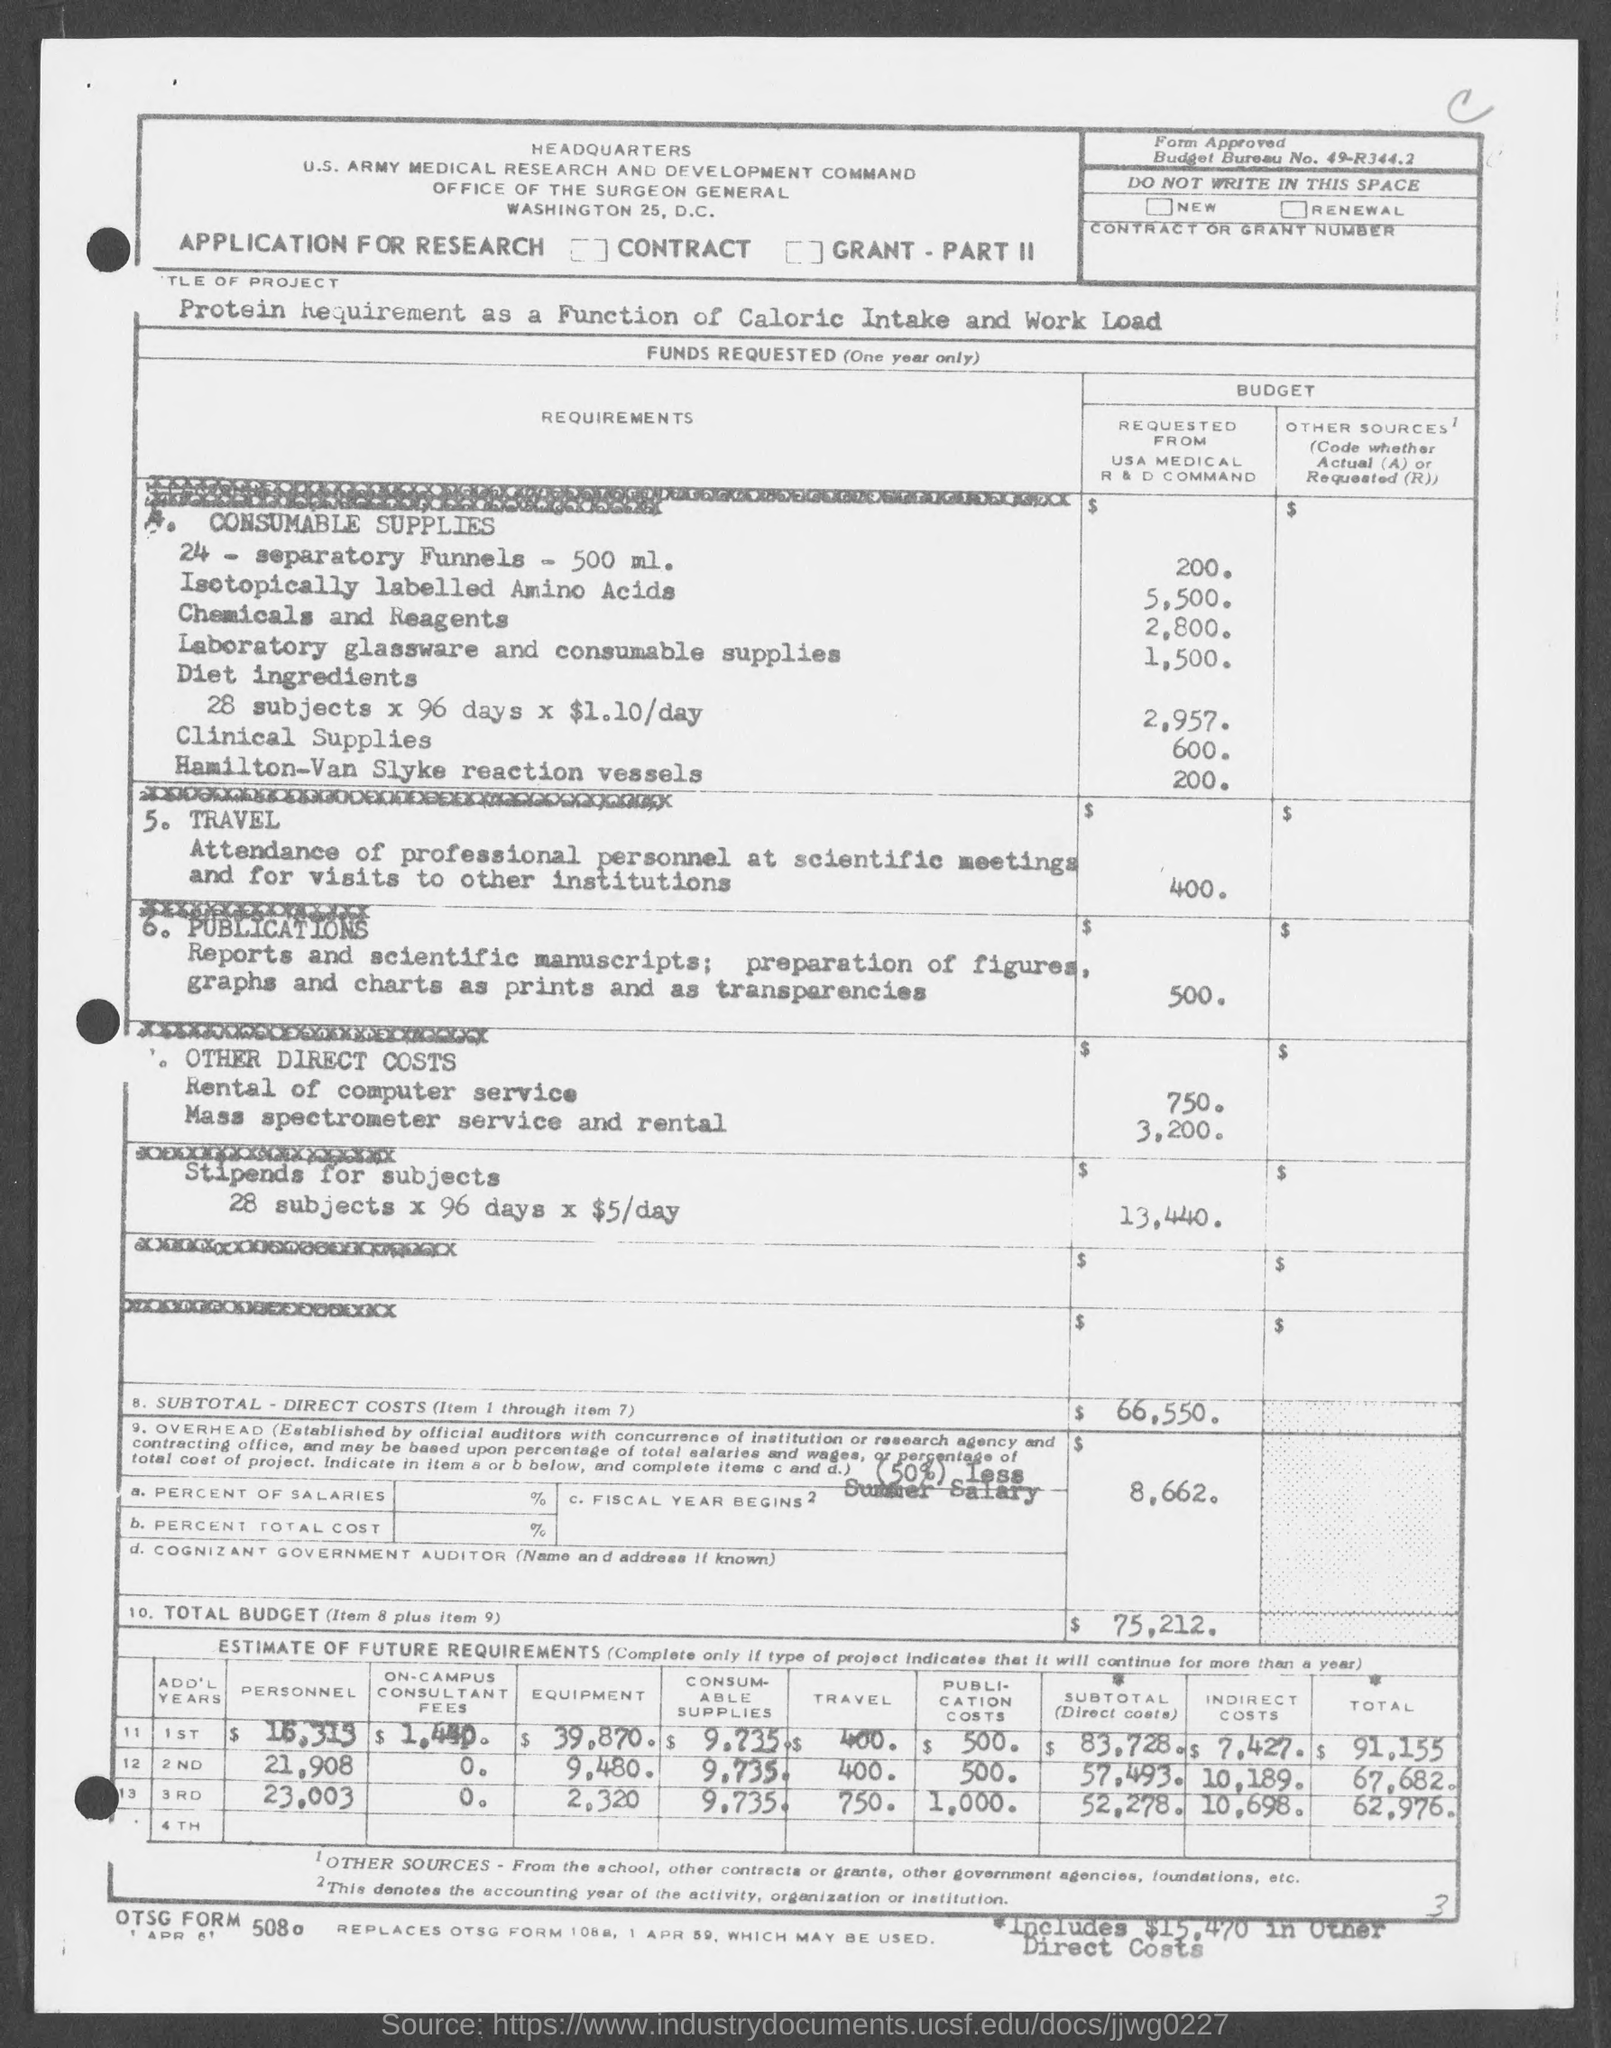What is the Budget for 24 separatory funnels?
Provide a succinct answer. 200. What is the Budget for Isotopocally Labelled Amino Acids?
Provide a short and direct response. 5,500. What is the Budget for Chemicals and Reagants?
Give a very brief answer. 2,800. What is the Budget for Laboratory Glassware and consumable supplies?
Your answer should be very brief. 1,500. What is the Budget for Clinical Supplies?
Your response must be concise. 600. What is the Budget for Hamilton-Van Slyke reaction vessels?
Keep it short and to the point. 200. What is the Budget for Rental of computer services?
Provide a succinct answer. 750. What is the Budget for Mass sprectrometer services and Rentals?
Offer a very short reply. 3,200. What is the Budget for Diet Ingredients 28 subjects x % days x $1.10/day?
Make the answer very short. 2,957. What is the Total Budget?
Provide a short and direct response. $75,212. 